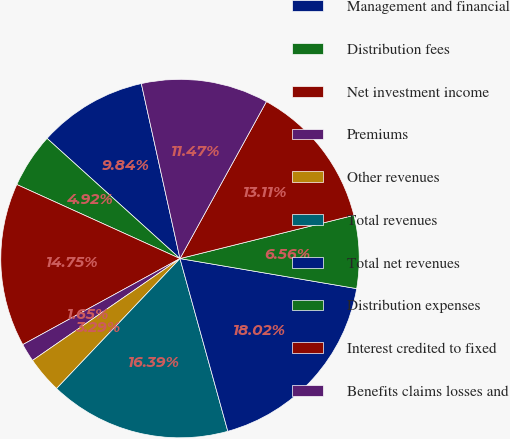Convert chart. <chart><loc_0><loc_0><loc_500><loc_500><pie_chart><fcel>Management and financial<fcel>Distribution fees<fcel>Net investment income<fcel>Premiums<fcel>Other revenues<fcel>Total revenues<fcel>Total net revenues<fcel>Distribution expenses<fcel>Interest credited to fixed<fcel>Benefits claims losses and<nl><fcel>9.84%<fcel>4.92%<fcel>14.75%<fcel>1.65%<fcel>3.29%<fcel>16.39%<fcel>18.02%<fcel>6.56%<fcel>13.11%<fcel>11.47%<nl></chart> 